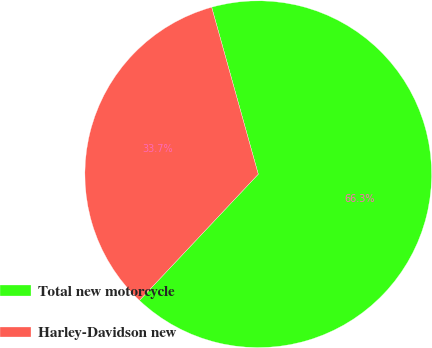<chart> <loc_0><loc_0><loc_500><loc_500><pie_chart><fcel>Total new motorcycle<fcel>Harley-Davidson new<nl><fcel>66.35%<fcel>33.65%<nl></chart> 